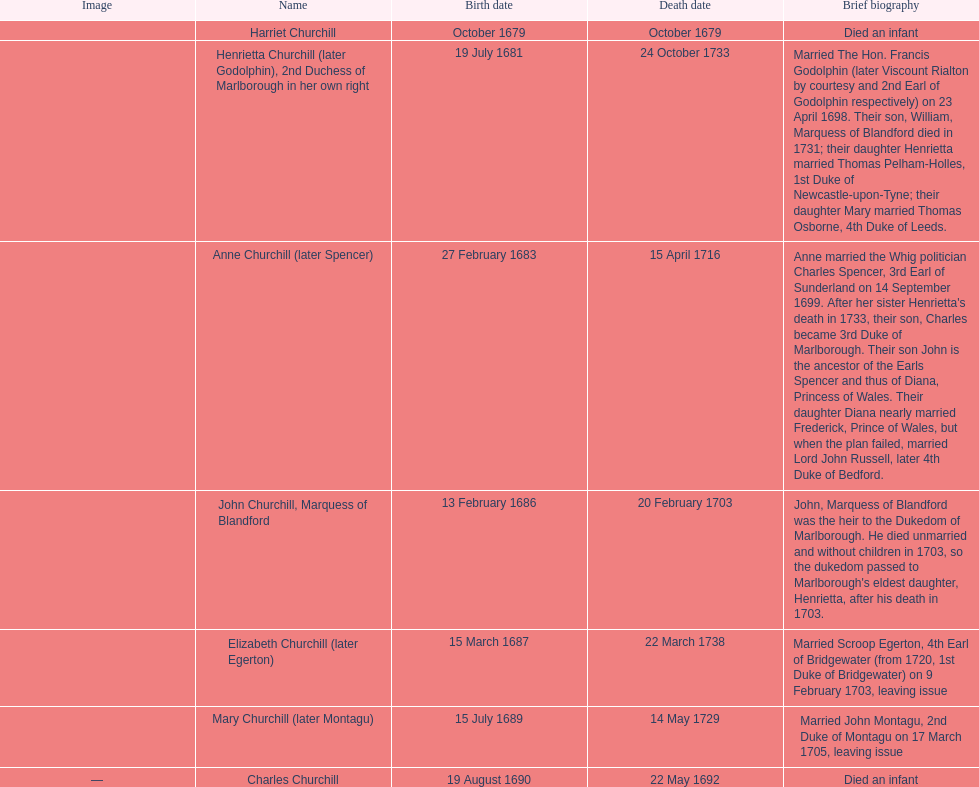Who was born before henrietta churchhill? Harriet Churchill. 